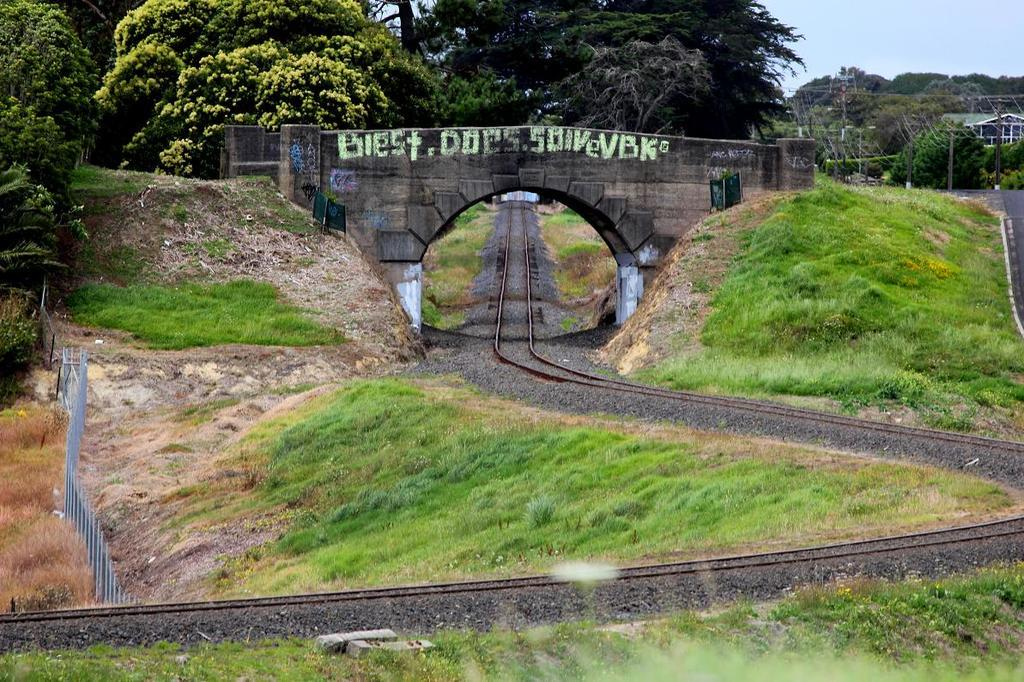<image>
Write a terse but informative summary of the picture. A bridge has graffiti written on it, saying "biest does soivevbk." 